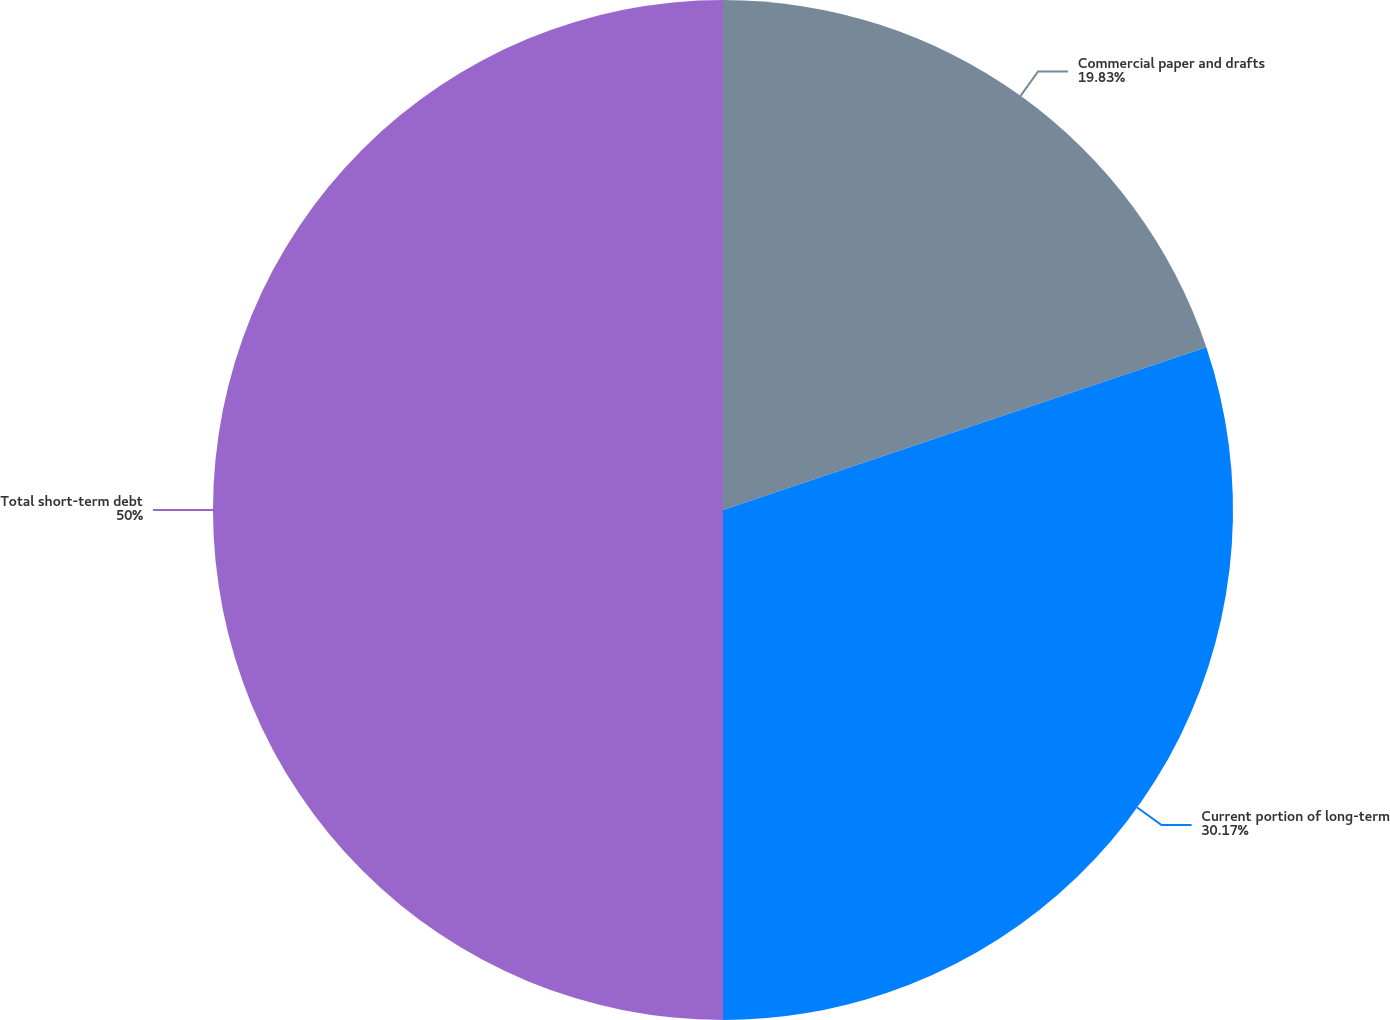Convert chart. <chart><loc_0><loc_0><loc_500><loc_500><pie_chart><fcel>Commercial paper and drafts<fcel>Current portion of long-term<fcel>Total short-term debt<nl><fcel>19.83%<fcel>30.17%<fcel>50.0%<nl></chart> 